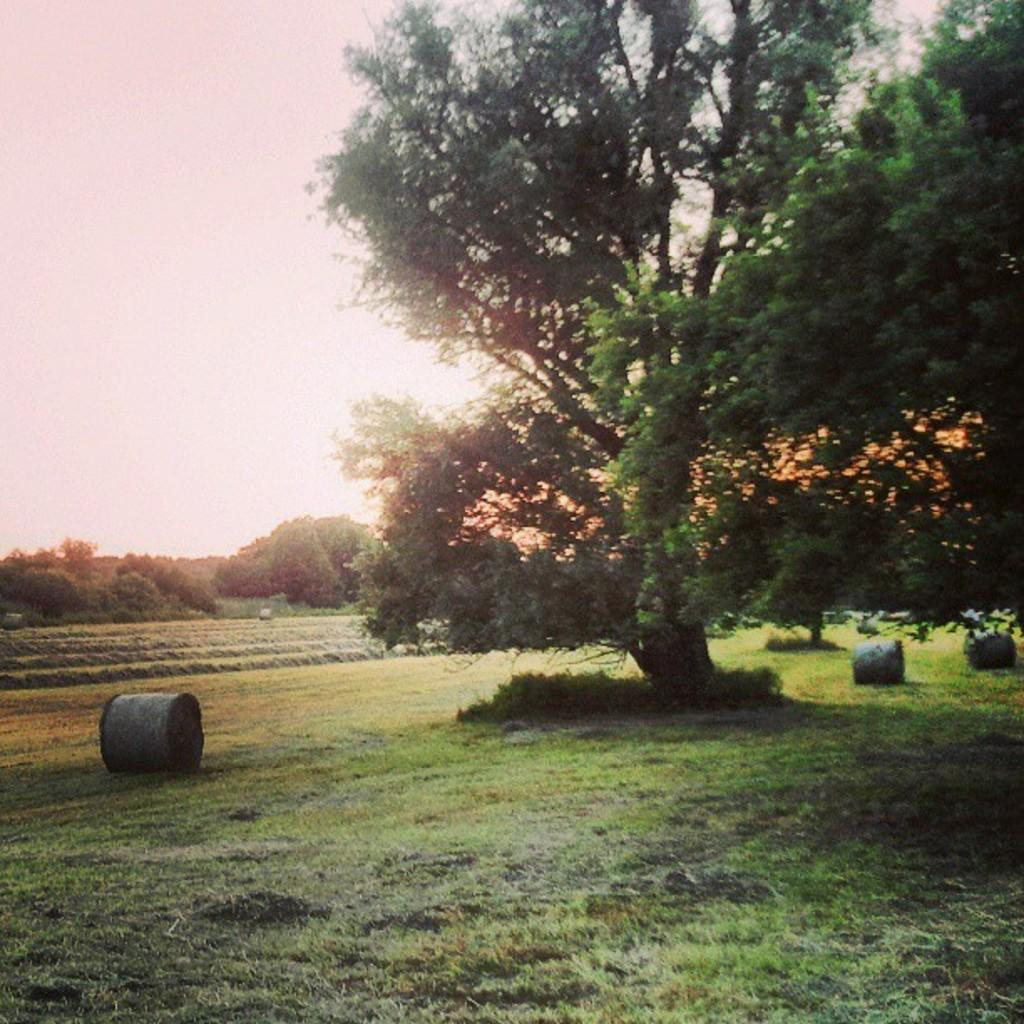What is placed on the grass in the image? There are rolls on the grass in the image. What type of natural environment is visible in the image? There are trees and plants visible in the image. What can be seen in the background of the image? The sky is visible in the background of the image. What word is written in the grass in the image? There is no word written in the grass in the image. Is there any quicksand visible in the image? There is no quicksand present in the image. 